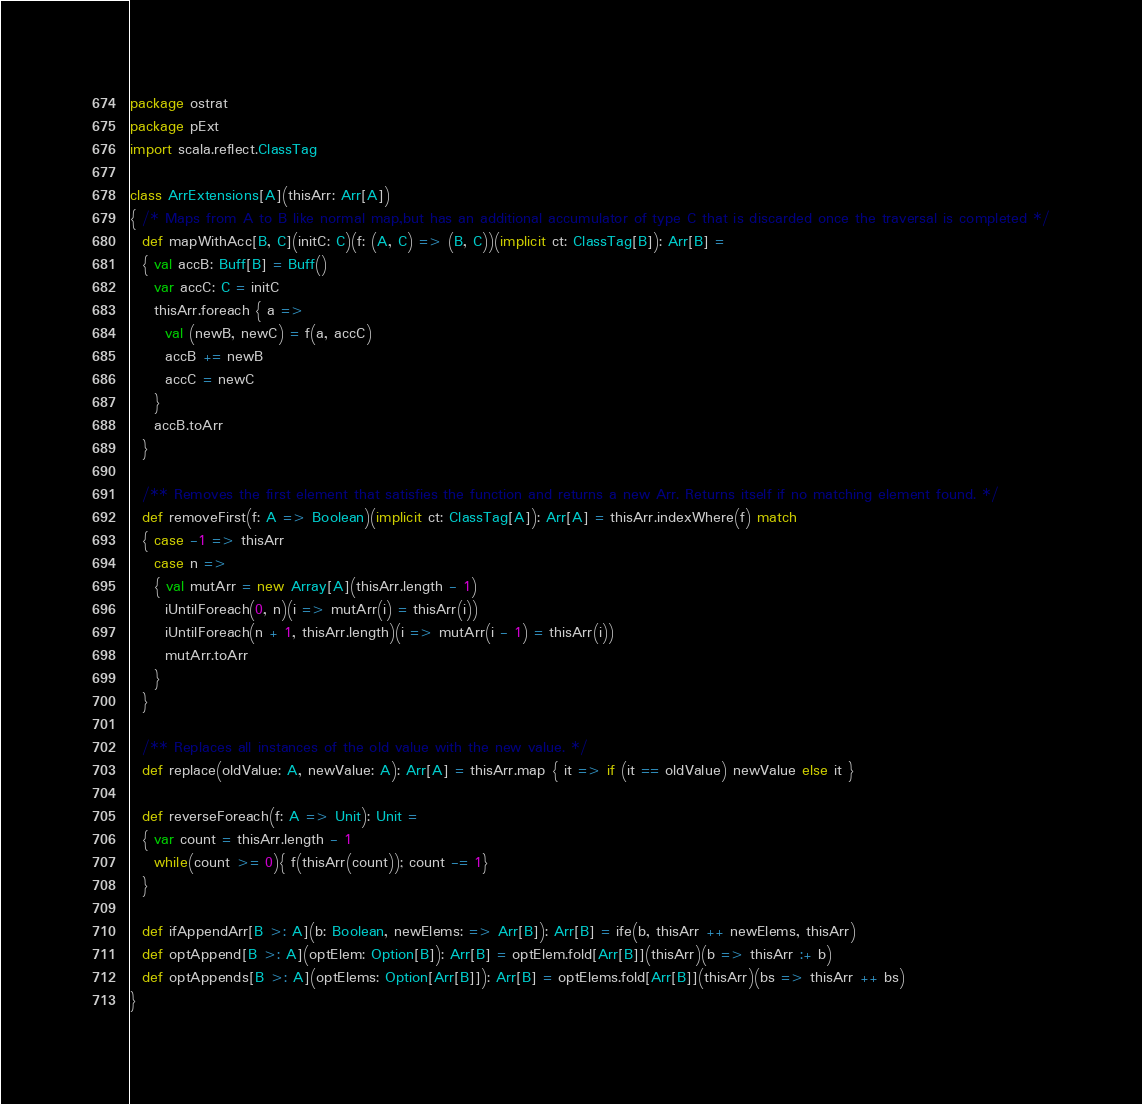Convert code to text. <code><loc_0><loc_0><loc_500><loc_500><_Scala_>package ostrat
package pExt
import scala.reflect.ClassTag

class ArrExtensions[A](thisArr: Arr[A])
{ /* Maps from A to B like normal map,but has an additional accumulator of type C that is discarded once the traversal is completed */
  def mapWithAcc[B, C](initC: C)(f: (A, C) => (B, C))(implicit ct: ClassTag[B]): Arr[B] =
  { val accB: Buff[B] = Buff()
    var accC: C = initC
    thisArr.foreach { a =>
      val (newB, newC) = f(a, accC)
      accB += newB
      accC = newC
    }
    accB.toArr
  }

  /** Removes the first element that satisfies the function and returns a new Arr. Returns itself if no matching element found. */
  def removeFirst(f: A => Boolean)(implicit ct: ClassTag[A]): Arr[A] = thisArr.indexWhere(f) match
  { case -1 => thisArr
    case n =>
    { val mutArr = new Array[A](thisArr.length - 1)
      iUntilForeach(0, n)(i => mutArr(i) = thisArr(i))
      iUntilForeach(n + 1, thisArr.length)(i => mutArr(i - 1) = thisArr(i))
      mutArr.toArr
    }
  }

  /** Replaces all instances of the old value with the new value. */
  def replace(oldValue: A, newValue: A): Arr[A] = thisArr.map { it => if (it == oldValue) newValue else it }

  def reverseForeach(f: A => Unit): Unit =
  { var count = thisArr.length - 1
    while(count >= 0){ f(thisArr(count)); count -= 1}
  }

  def ifAppendArr[B >: A](b: Boolean, newElems: => Arr[B]): Arr[B] = ife(b, thisArr ++ newElems, thisArr)
  def optAppend[B >: A](optElem: Option[B]): Arr[B] = optElem.fold[Arr[B]](thisArr)(b => thisArr :+ b)
  def optAppends[B >: A](optElems: Option[Arr[B]]): Arr[B] = optElems.fold[Arr[B]](thisArr)(bs => thisArr ++ bs)
}</code> 